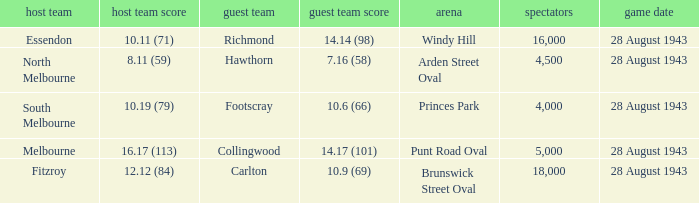Where was the game played with an away team score of 14.17 (101)? Punt Road Oval. 